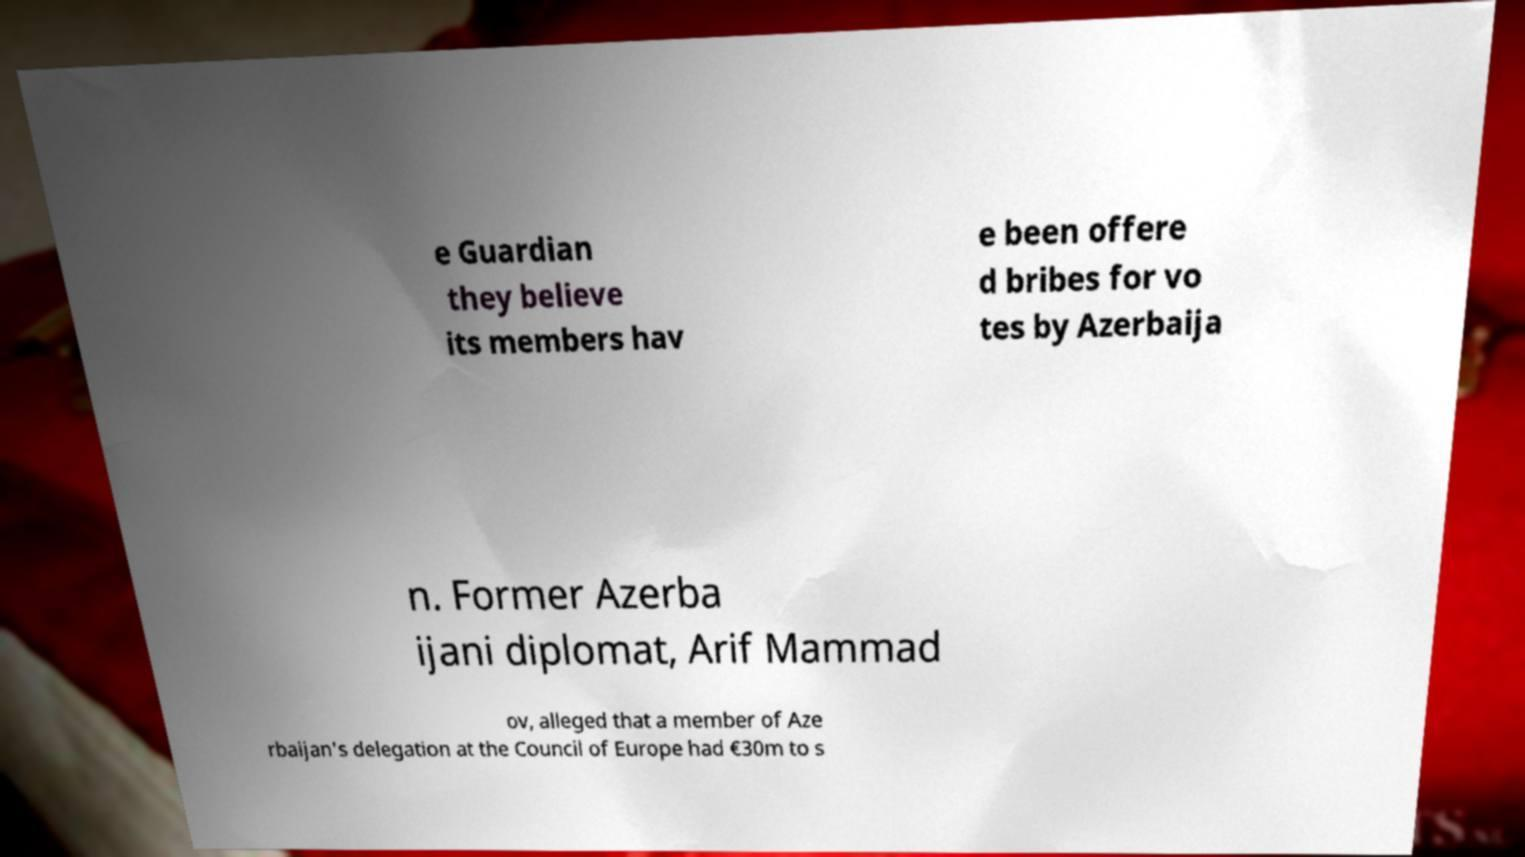Could you extract and type out the text from this image? e Guardian they believe its members hav e been offere d bribes for vo tes by Azerbaija n. Former Azerba ijani diplomat, Arif Mammad ov, alleged that a member of Aze rbaijan's delegation at the Council of Europe had €30m to s 